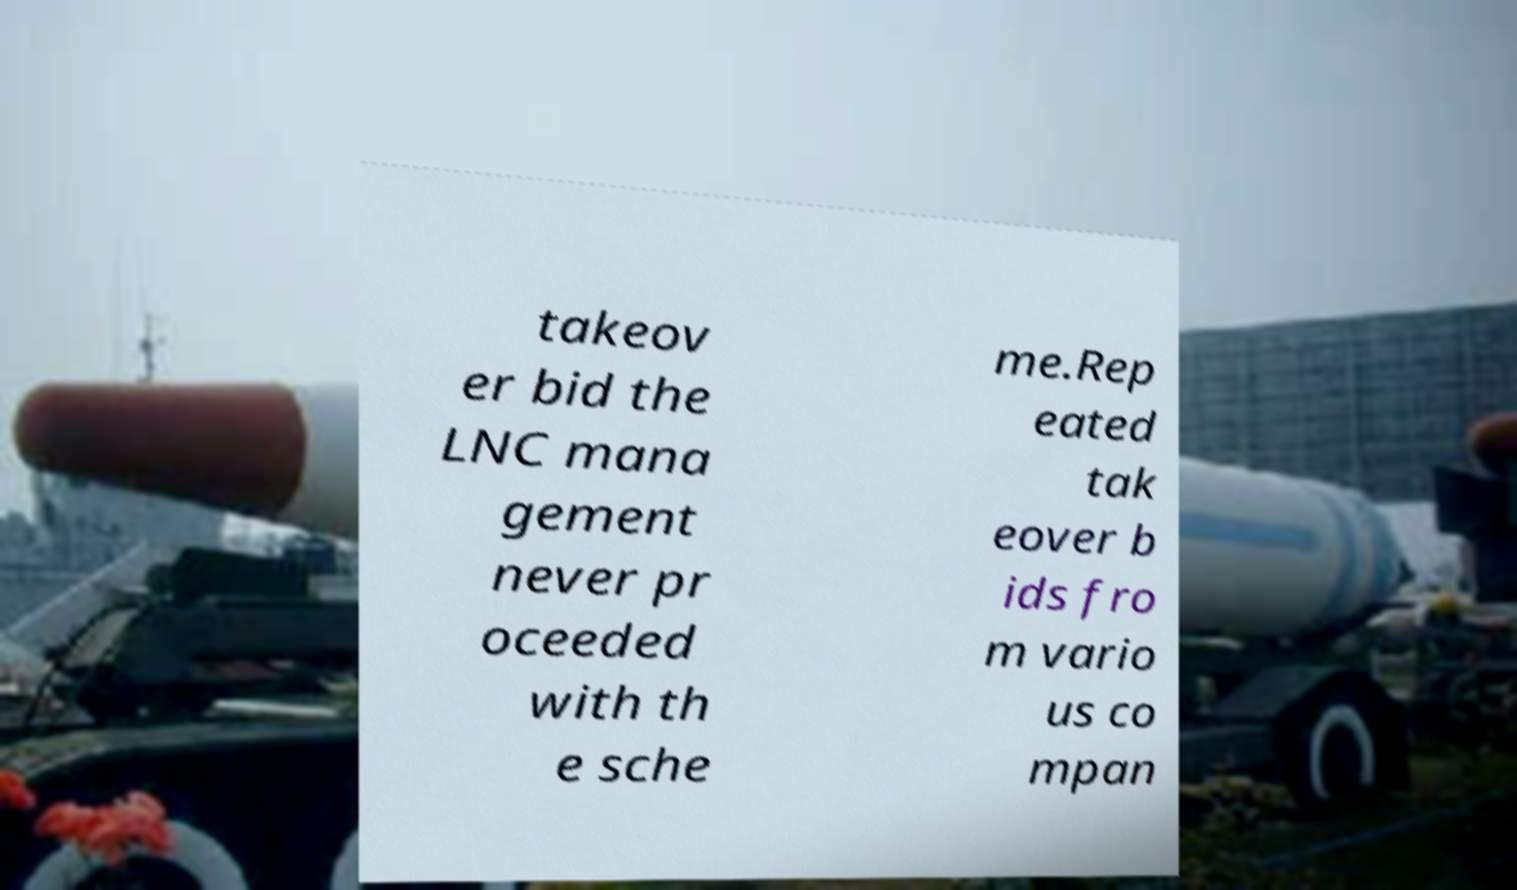Please identify and transcribe the text found in this image. takeov er bid the LNC mana gement never pr oceeded with th e sche me.Rep eated tak eover b ids fro m vario us co mpan 